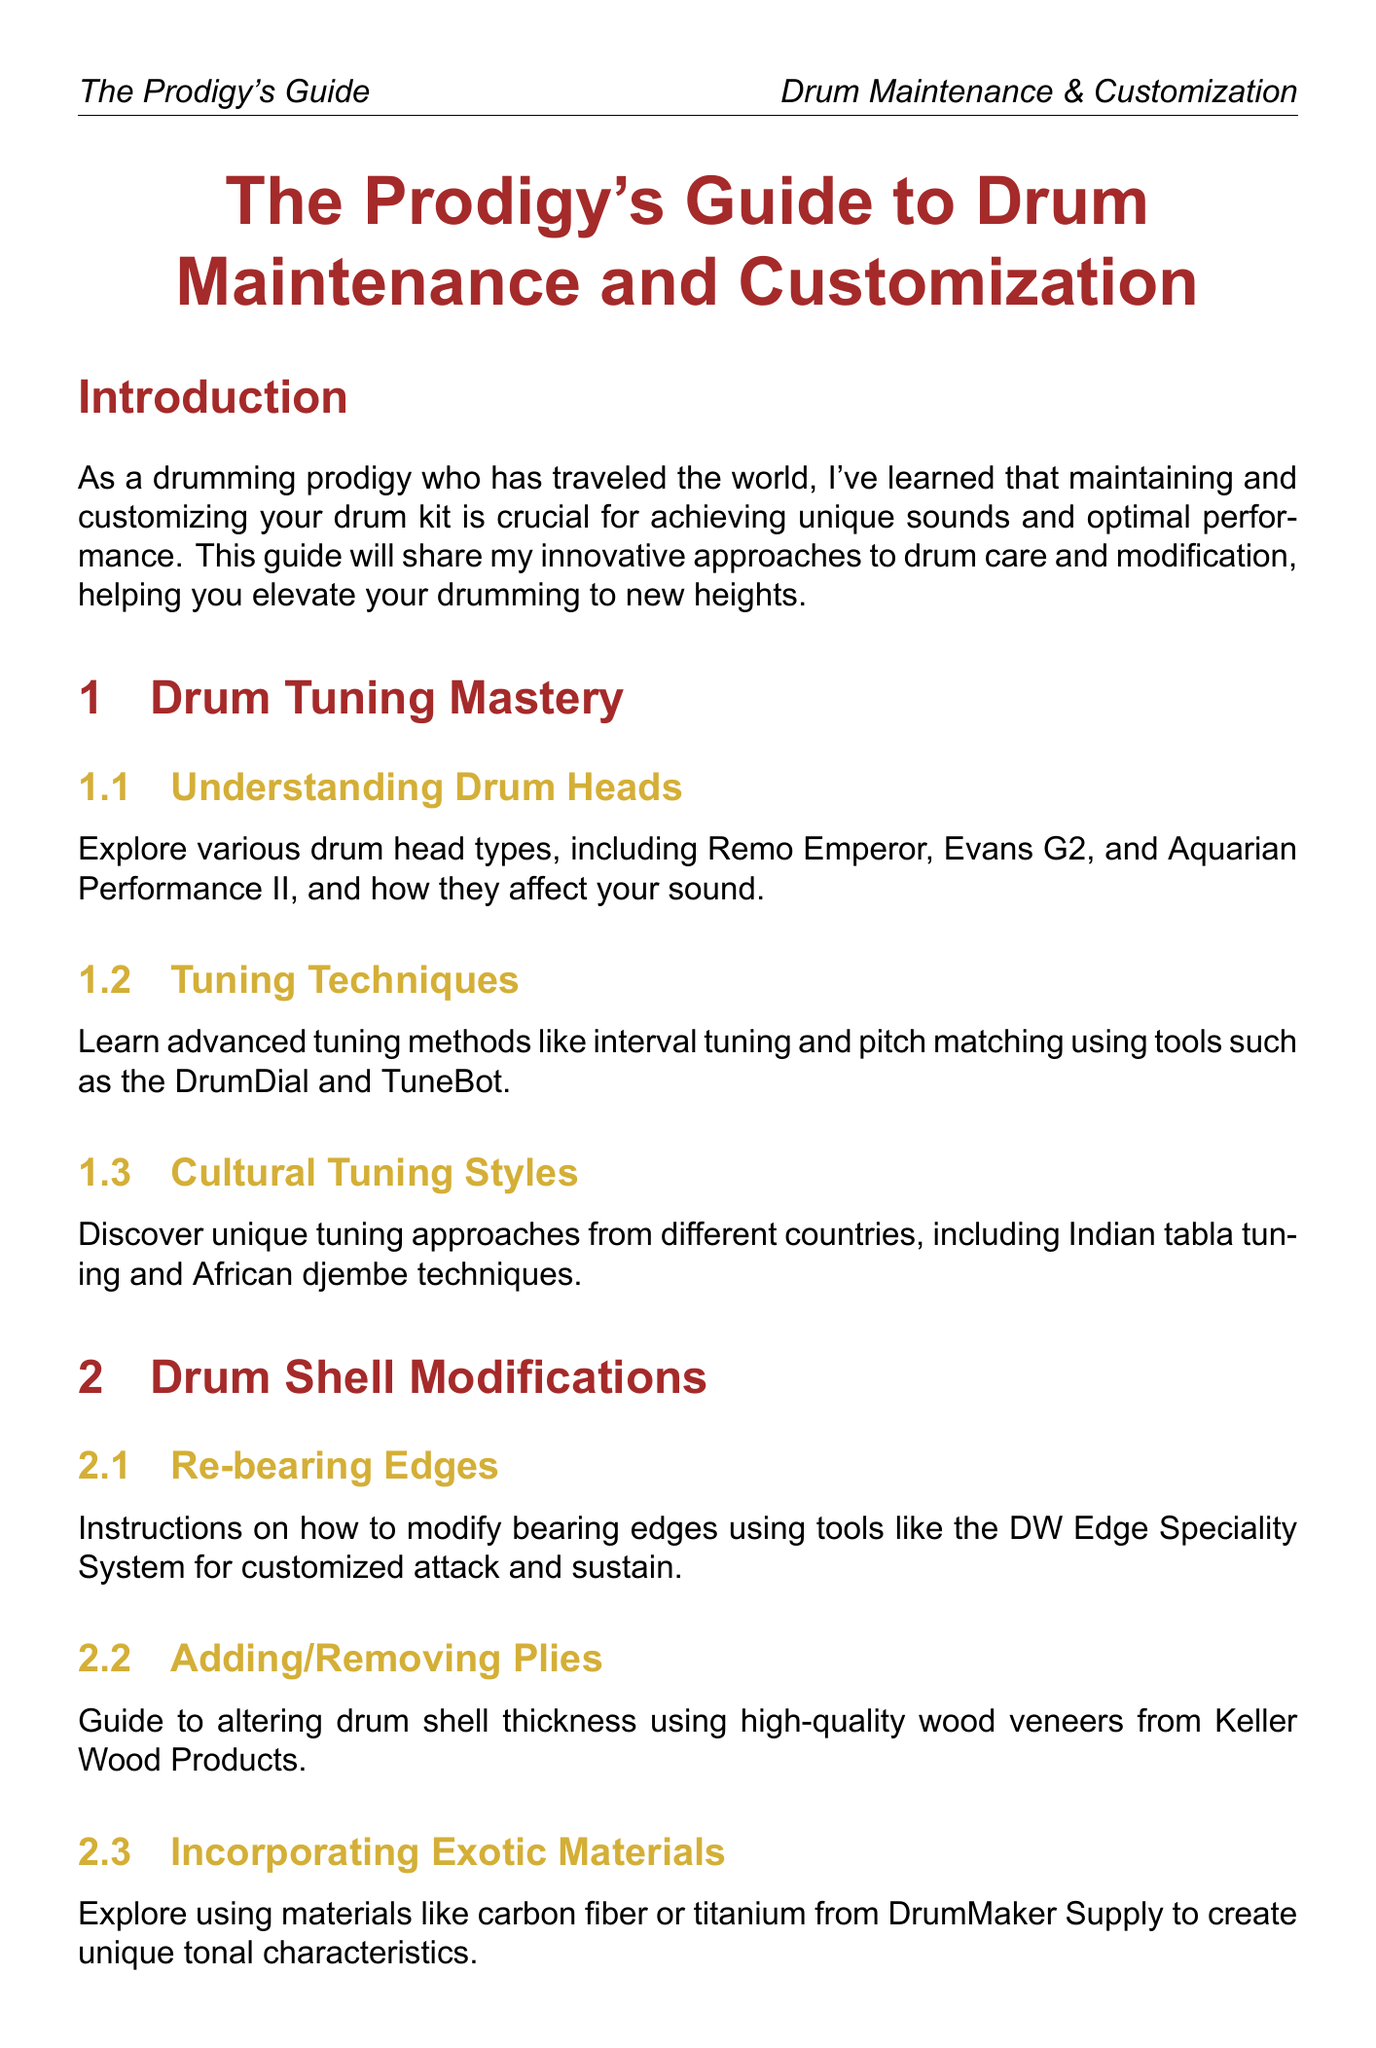what is the title of the manual? The title is presented at the beginning of the document.
Answer: The Prodigy's Guide to Drum Maintenance and Customization how many chapters are included in the document? The number of chapters is mentioned in the structure of the document.
Answer: 6 what tool is recommended for tuning techniques? The document specifies tools used for advanced tuning methods.
Answer: DrumDial which section covers integrating triggers? This section's title identifies where the topic is discussed in the document.
Answer: Electronic Augmentation what is one method suggested for incorporating found objects? The guide outlines techniques for using objects from travels; the specific method is found in a section title.
Answer: Guide to safely attaching and using found objects what materials are suggested for damping techniques? The document provides cultural materials used for damping methods.
Answer: Indian fabric or African beads which product is suggested for daily care rituals? The specific product mentioned for maintenance routines can be found under that section.
Answer: Music Nomad's Drum Detailer what is the purpose of re-bearing edges? The function of this modification is stated in the corresponding section.
Answer: Customized attack and sustain which chapter discusses seasonal adjustments? The title of the chapter indicates seasonal changes in maintenance routines.
Answer: Maintenance Routines 